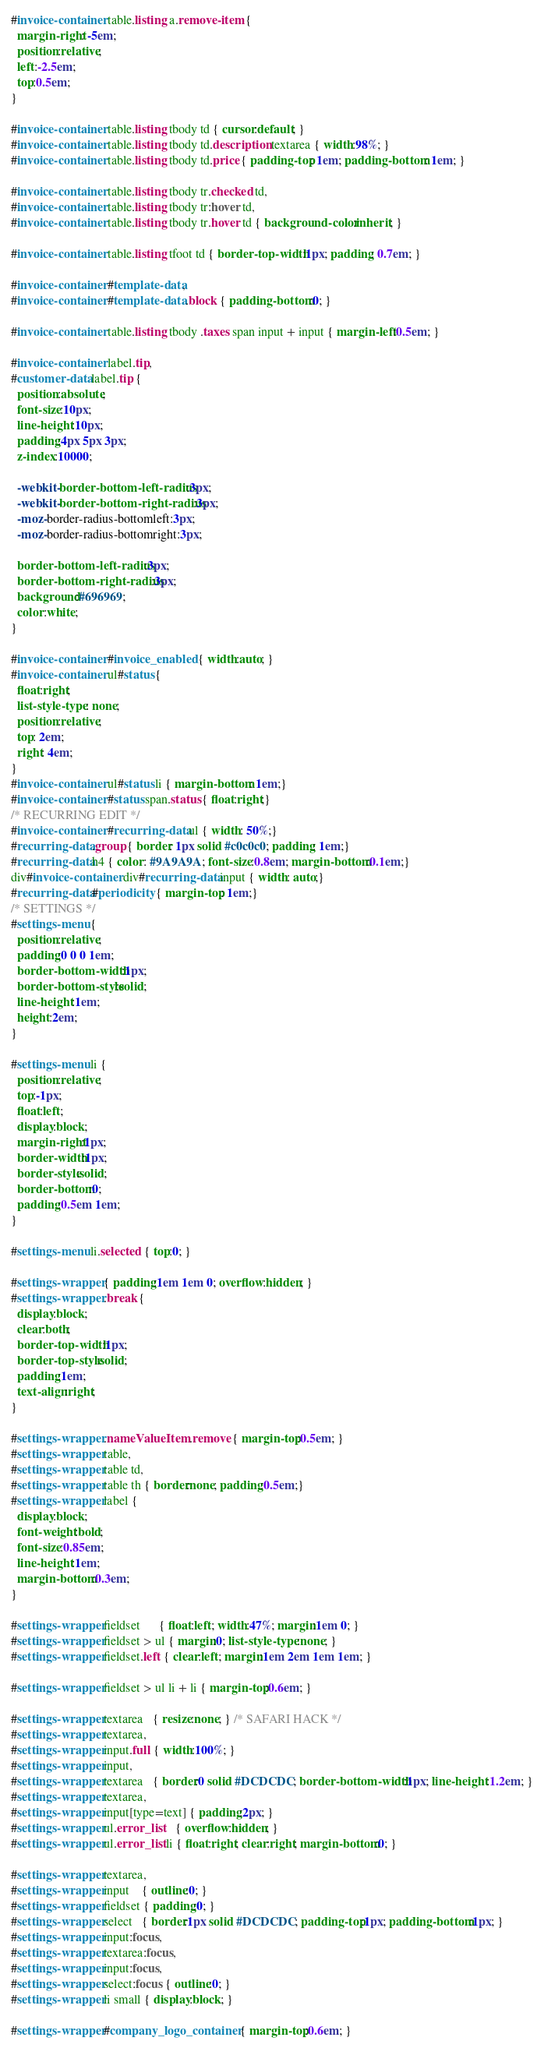<code> <loc_0><loc_0><loc_500><loc_500><_CSS_>
#invoice-container table.listing a.remove-item { 
  margin-right: -5em;
  position:relative;
  left:-2.5em;
  top:0.5em;
}

#invoice-container table.listing tbody td { cursor:default; }
#invoice-container table.listing tbody td.description textarea { width:98%; }
#invoice-container table.listing tbody td.price { padding-top: 1em; padding-bottom: 1em; }

#invoice-container table.listing tbody tr.checked td,
#invoice-container table.listing tbody tr:hover td,
#invoice-container table.listing tbody tr.hover td { background-color:inherit; }

#invoice-container table.listing tfoot td { border-top-width:1px; padding: 0.7em; }

#invoice-container #template-data,
#invoice-container #template-data .block { padding-bottom:0; }

#invoice-container table.listing tbody .taxes span input + input { margin-left:0.5em; }

#invoice-container label.tip,
#customer-data label.tip {
  position:absolute;
  font-size:10px;
  line-height:10px;
  padding:4px 5px 3px;
  z-index:10000;
  
  -webkit-border-bottom-left-radius:3px;
  -webkit-border-bottom-right-radius:3px;
  -moz-border-radius-bottomleft:3px;
  -moz-border-radius-bottomright:3px;
  
  border-bottom-left-radius:3px;
  border-bottom-right-radius:3px;
  background:#696969;
  color:white;
}

#invoice-container #invoice_enabled { width:auto; }
#invoice-container ul#status { 
  float:right;
  list-style-type: none;
  position:relative;
  top: 2em;
  right: 4em;
}
#invoice-container ul#status li { margin-bottom: 1em;}
#invoice-container #status span.status { float:right;}
/* RECURRING EDIT */
#invoice-container #recurring-data ul { width: 50%;}
#recurring-data .group { border: 1px solid #c0c0c0; padding: 1em;}
#recurring-data h4 { color: #9A9A9A; font-size:0.8em; margin-bottom:0.1em;}
div#invoice-container div#recurring-data input { width: auto;}
#recurring-data #periodicity { margin-top: 1em;}
/* SETTINGS */
#settings-menu {
  position:relative;
  padding:0 0 0 1em;
  border-bottom-width:1px;
  border-bottom-style:solid;
  line-height:1em;
  height:2em;
}

#settings-menu li {
  position:relative;
  top:-1px;
  float:left;
  display:block;
  margin-right:1px;
  border-width:1px;
  border-style:solid;
  border-bottom:0;
  padding:0.5em 1em;
}

#settings-menu li.selected { top:0; }

#settings-wrapper { padding:1em 1em 0; overflow:hidden; }
#settings-wrapper .break {
  display:block;
  clear:both;
  border-top-width:1px;
  border-top-style:solid;
  padding:1em;
  text-align:right;
}

#settings-wrapper .nameValueItem .remove { margin-top:0.5em; }
#settings-wrapper table, 
#settings-wrapper table td,
#settings-wrapper table th { border:none; padding:0.5em;}
#settings-wrapper label {
  display:block;
  font-weight:bold;
  font-size:0.85em;
  line-height:1em;
  margin-bottom:0.3em;
}

#settings-wrapper fieldset      { float:left; width:47%; margin:1em 0; }
#settings-wrapper fieldset > ul { margin:0; list-style-type:none; }
#settings-wrapper fieldset.left { clear:left; margin:1em 2em 1em 1em; }

#settings-wrapper fieldset > ul li + li { margin-top:0.6em; }

#settings-wrapper textarea   { resize:none; } /* SAFARI HACK */
#settings-wrapper textarea,
#settings-wrapper input.full { width:100%; }
#settings-wrapper input,
#settings-wrapper textarea   { border:0 solid #DCDCDC; border-bottom-width:1px; line-height:1.2em; }
#settings-wrapper textarea,
#settings-wrapper input[type=text] { padding:2px; }
#settings-wrapper ul.error_list    { overflow:hidden; }
#settings-wrapper ul.error_list li { float:right; clear:right; margin-bottom:0; }

#settings-wrapper textarea,
#settings-wrapper input    { outline:0; }
#settings-wrapper fieldset { padding:0; }
#settings-wrapper select   { border:1px solid #DCDCDC; padding-top:1px; padding-bottom:1px; }
#settings-wrapper input:focus,
#settings-wrapper textarea:focus,
#settings-wrapper input:focus,
#settings-wrapper select:focus { outline:0; }
#settings-wrapper li small { display:block; }

#settings-wrapper #company_logo_container { margin-top:0.6em; }</code> 